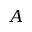Convert formula to latex. <formula><loc_0><loc_0><loc_500><loc_500>A</formula> 